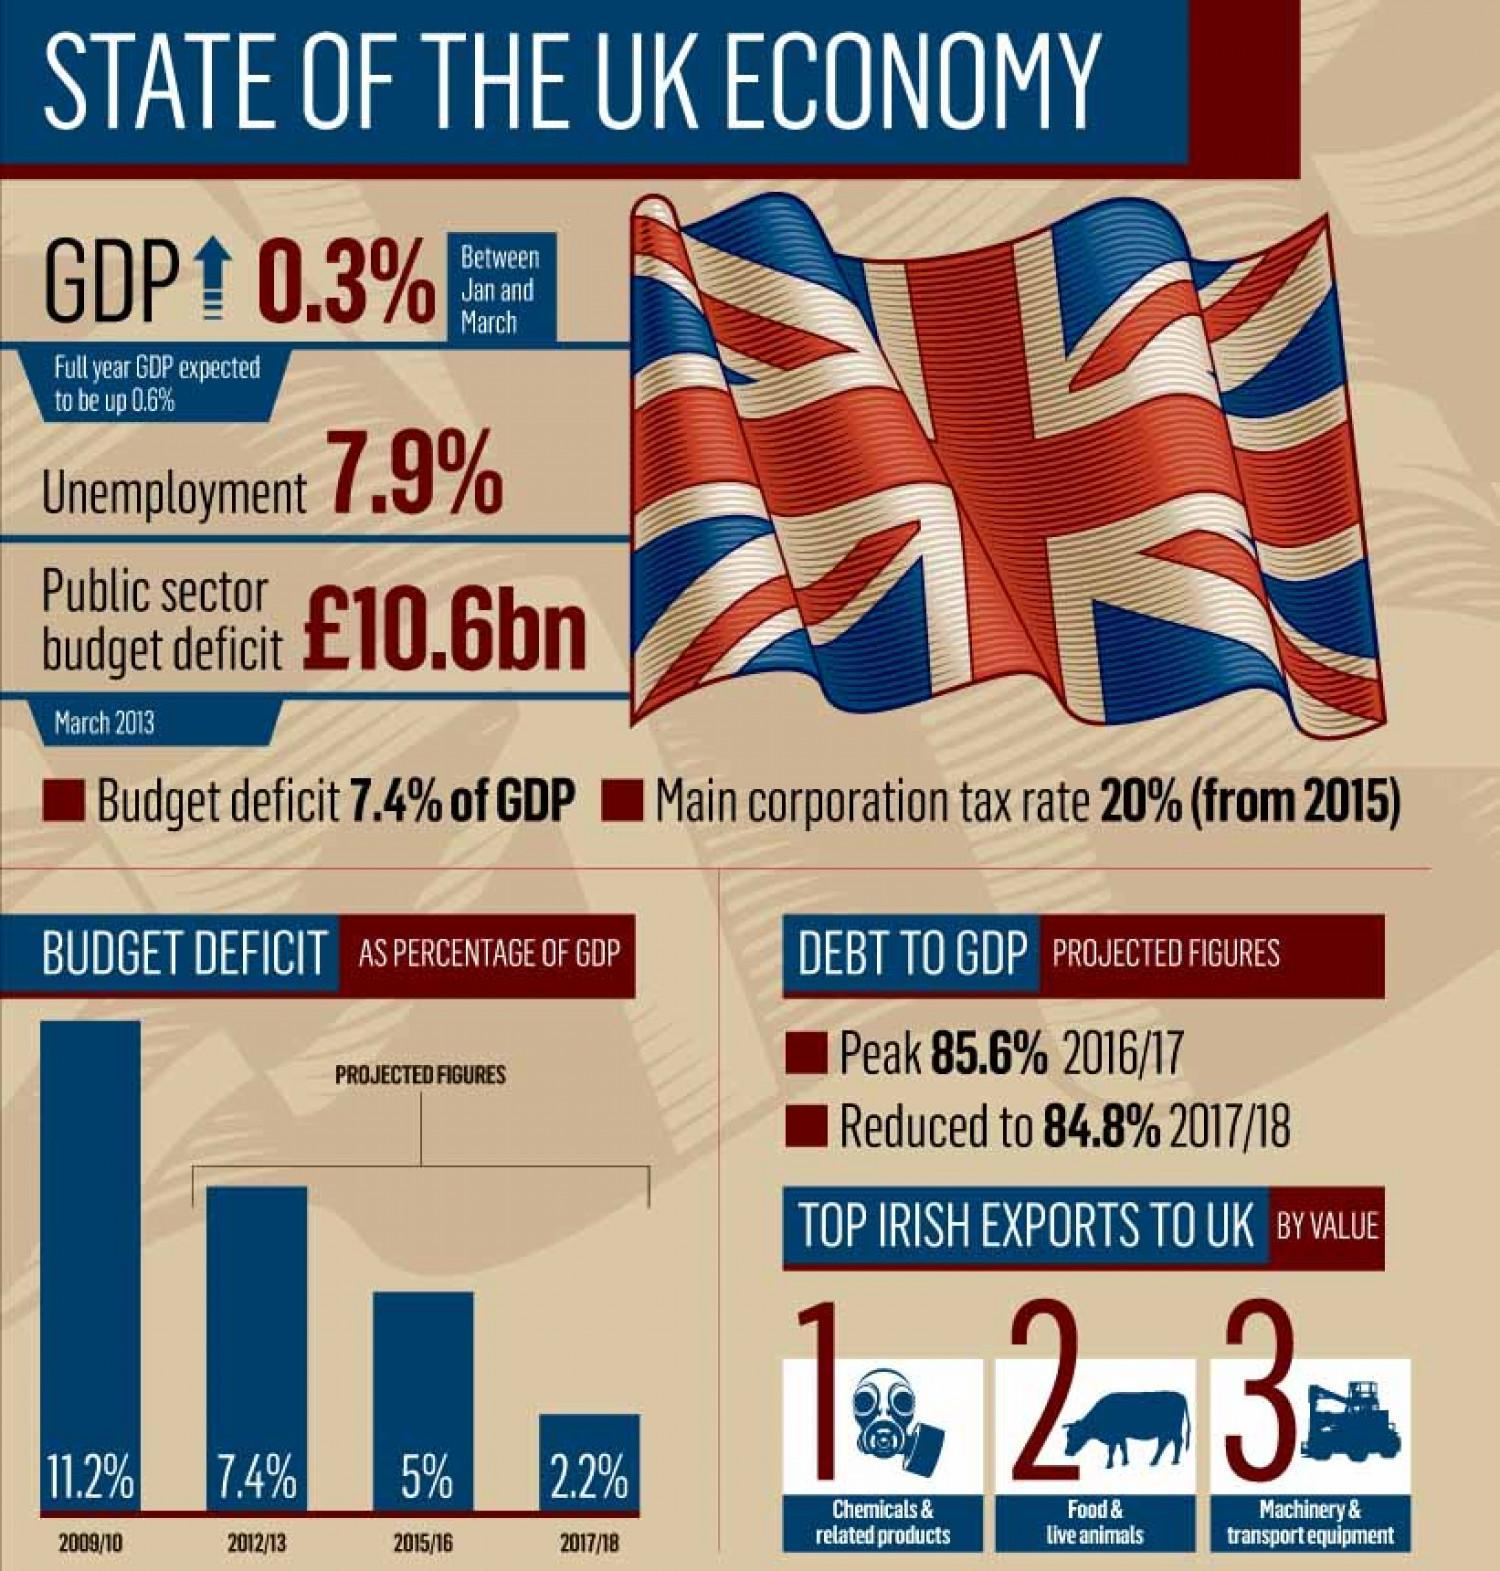In which year third highest GDP of UK is observed?
Answer the question with a short phrase. 2015/16 Which is the third most Irish export to UK by value? Machinery & transport equipment In which year second highest GDP of UK is observed? 2012/13 Which is the second most Irish export to UK by value? Food & live animals How much the GDP percentage of UK got reduced from 2016 to 2018? 0.8 